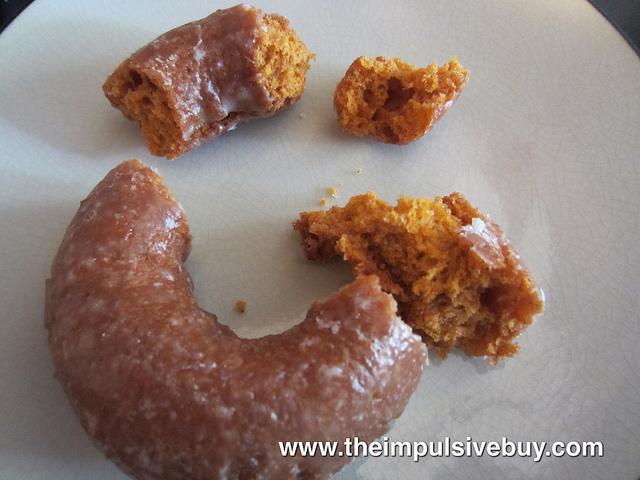What type of food is this?
Write a very short answer. Donut. Could this be finger food?
Give a very brief answer. Yes. How many pieces are there on the plate?
Concise answer only. 4. What kind of desert is this?
Answer briefly. Donut. Is there meat on this plate?
Give a very brief answer. No. 